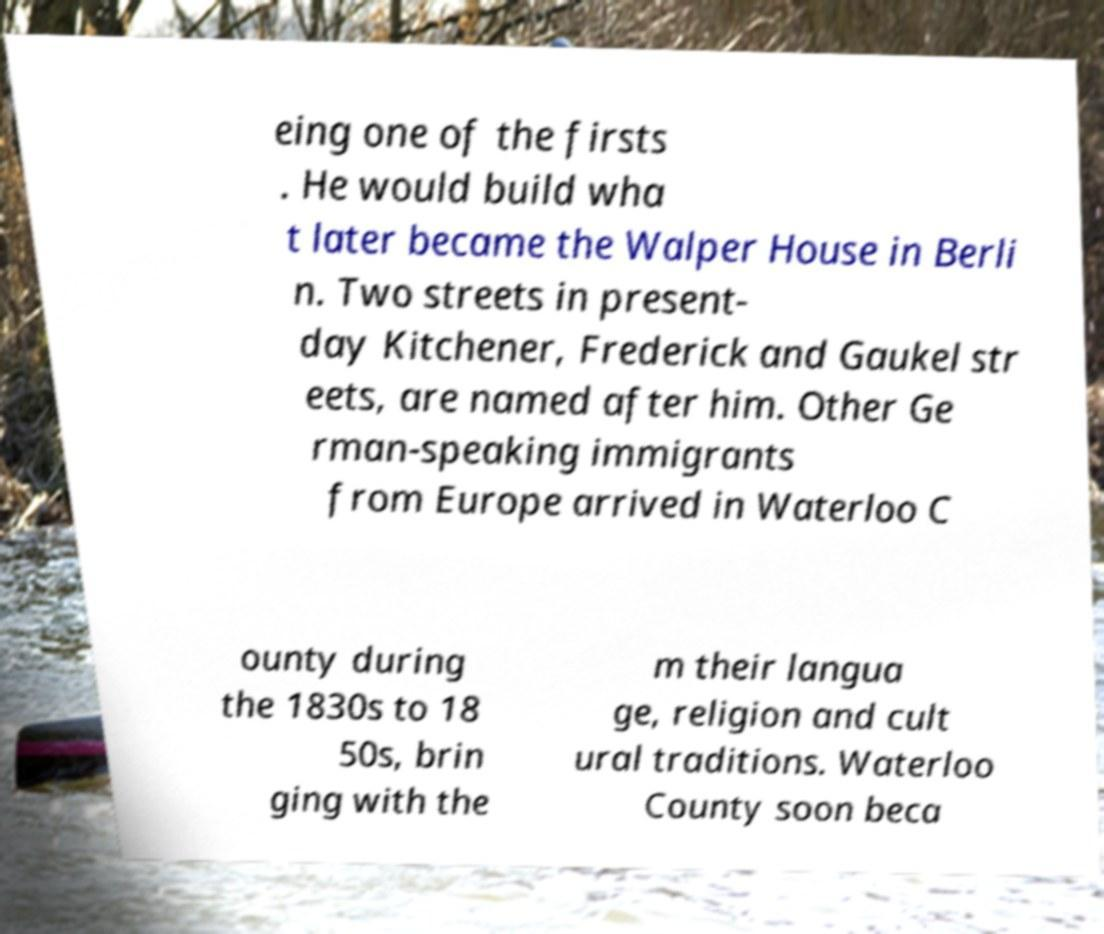Could you extract and type out the text from this image? eing one of the firsts . He would build wha t later became the Walper House in Berli n. Two streets in present- day Kitchener, Frederick and Gaukel str eets, are named after him. Other Ge rman-speaking immigrants from Europe arrived in Waterloo C ounty during the 1830s to 18 50s, brin ging with the m their langua ge, religion and cult ural traditions. Waterloo County soon beca 